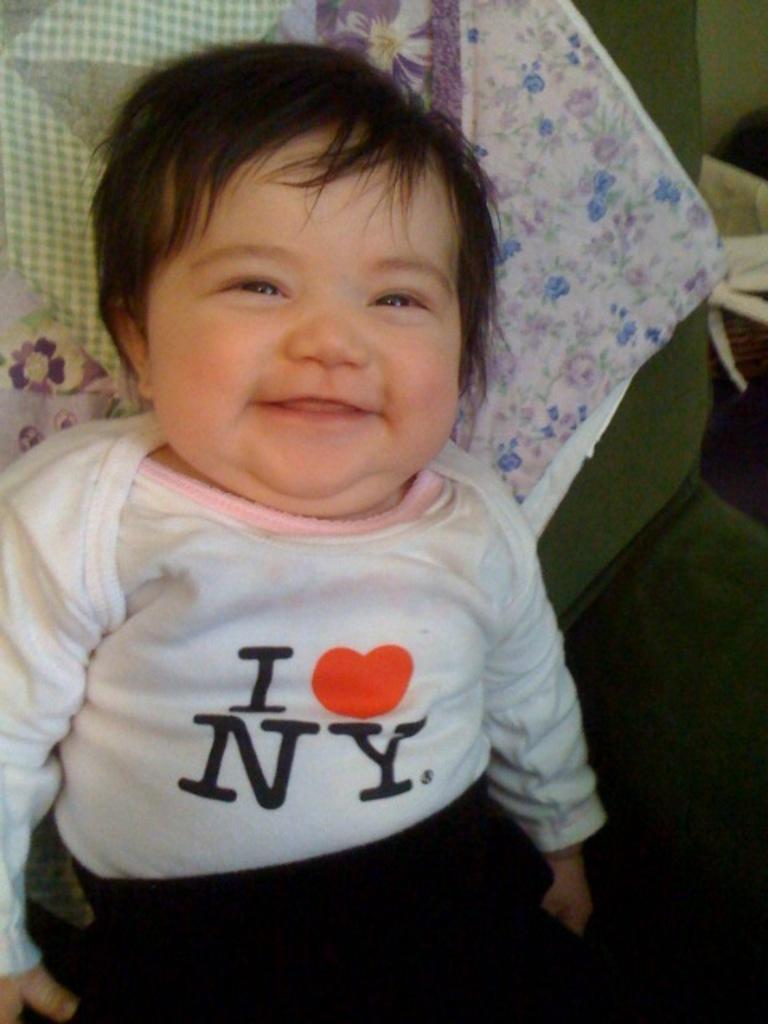Describe this image in one or two sentences. In this image I can see a little boy is smiling. He wore white color t-shirt and black color short. 